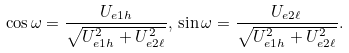Convert formula to latex. <formula><loc_0><loc_0><loc_500><loc_500>\cos \omega = \frac { U _ { e 1 h } } { \sqrt { U ^ { 2 } _ { e 1 h } + U ^ { 2 } _ { e 2 \ell } } } , \, \sin \omega = \frac { U _ { e 2 \ell } } { \sqrt { U ^ { 2 } _ { e 1 h } + U ^ { 2 } _ { e 2 \ell } } } .</formula> 